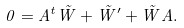<formula> <loc_0><loc_0><loc_500><loc_500>0 = A ^ { t } \tilde { W } + \tilde { W } ^ { \prime } + \tilde { W } A .</formula> 